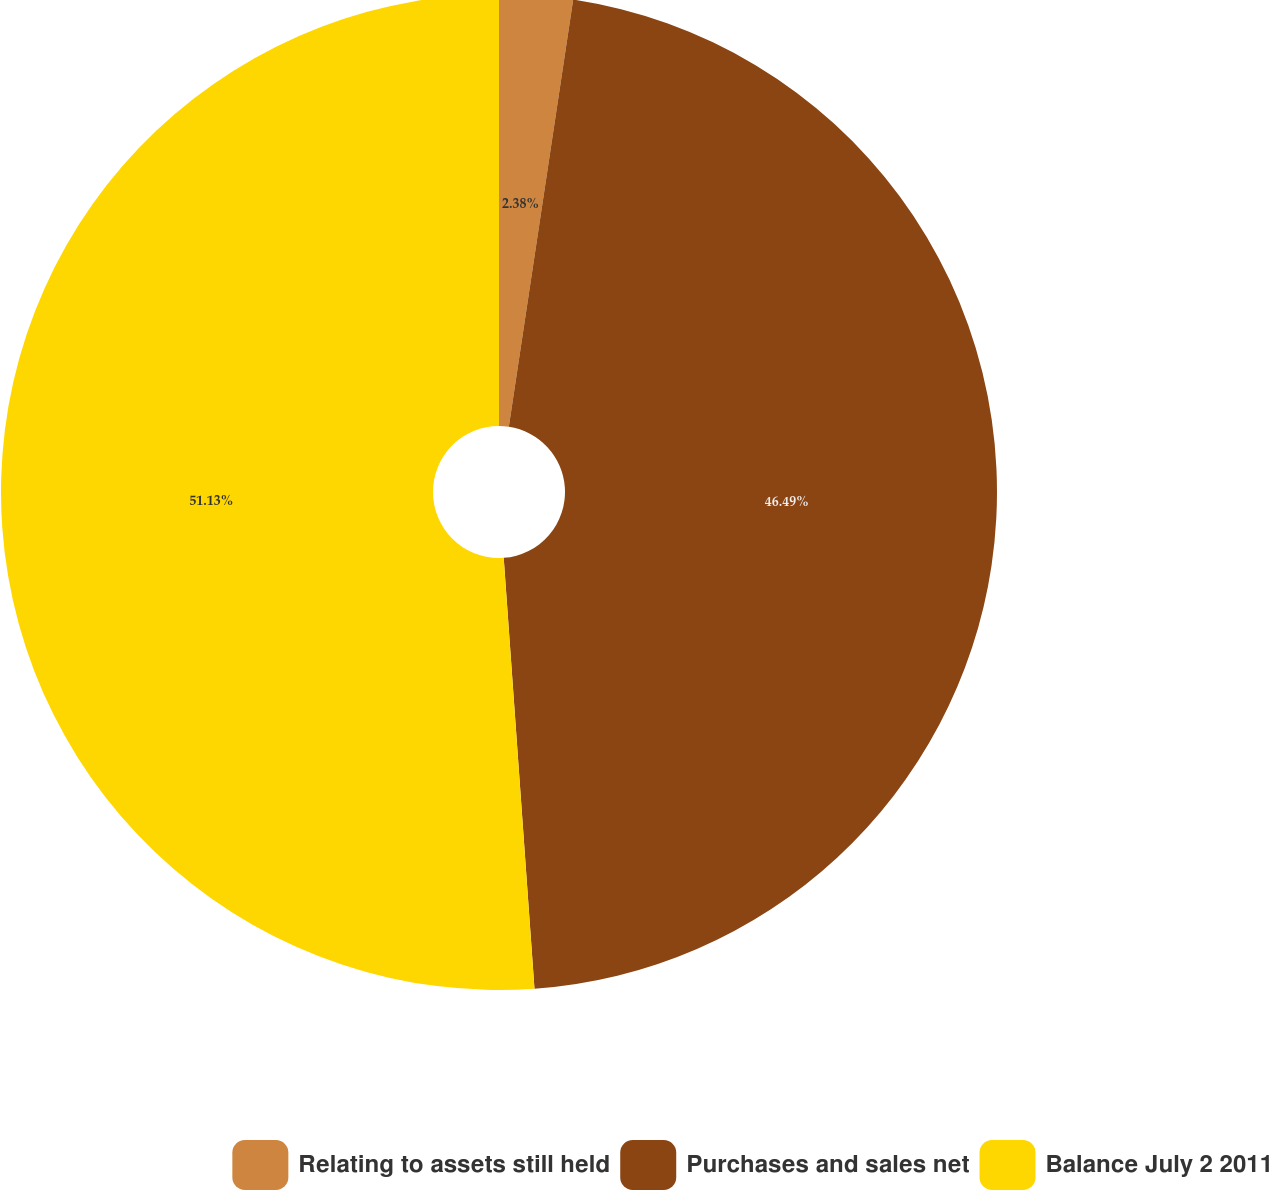Convert chart. <chart><loc_0><loc_0><loc_500><loc_500><pie_chart><fcel>Relating to assets still held<fcel>Purchases and sales net<fcel>Balance July 2 2011<nl><fcel>2.38%<fcel>46.49%<fcel>51.14%<nl></chart> 